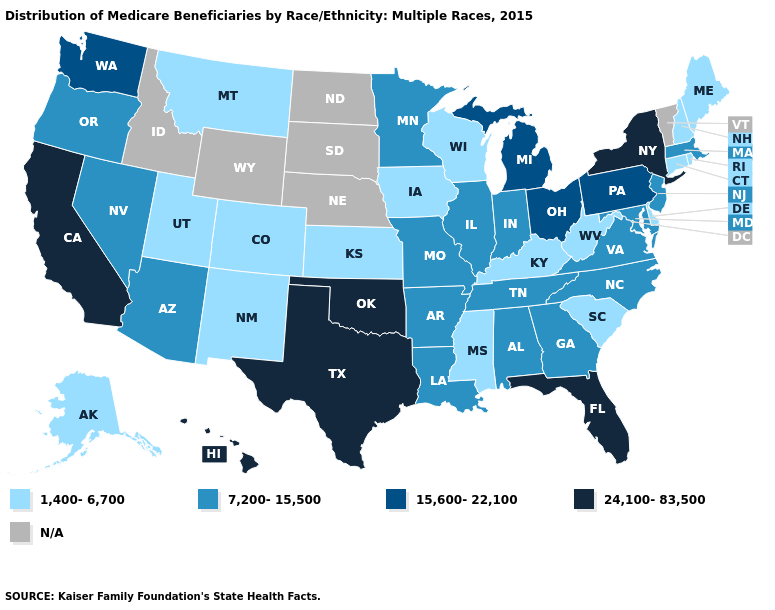Name the states that have a value in the range N/A?
Give a very brief answer. Idaho, Nebraska, North Dakota, South Dakota, Vermont, Wyoming. Among the states that border Michigan , does Indiana have the highest value?
Write a very short answer. No. What is the value of Arizona?
Give a very brief answer. 7,200-15,500. Does Connecticut have the lowest value in the Northeast?
Keep it brief. Yes. What is the highest value in states that border Connecticut?
Be succinct. 24,100-83,500. Name the states that have a value in the range 7,200-15,500?
Be succinct. Alabama, Arizona, Arkansas, Georgia, Illinois, Indiana, Louisiana, Maryland, Massachusetts, Minnesota, Missouri, Nevada, New Jersey, North Carolina, Oregon, Tennessee, Virginia. Does Hawaii have the highest value in the West?
Give a very brief answer. Yes. What is the lowest value in the South?
Keep it brief. 1,400-6,700. Which states hav the highest value in the South?
Concise answer only. Florida, Oklahoma, Texas. What is the lowest value in the USA?
Write a very short answer. 1,400-6,700. What is the value of California?
Quick response, please. 24,100-83,500. Among the states that border Maine , which have the highest value?
Concise answer only. New Hampshire. Does the map have missing data?
Concise answer only. Yes. What is the value of Colorado?
Quick response, please. 1,400-6,700. How many symbols are there in the legend?
Give a very brief answer. 5. 